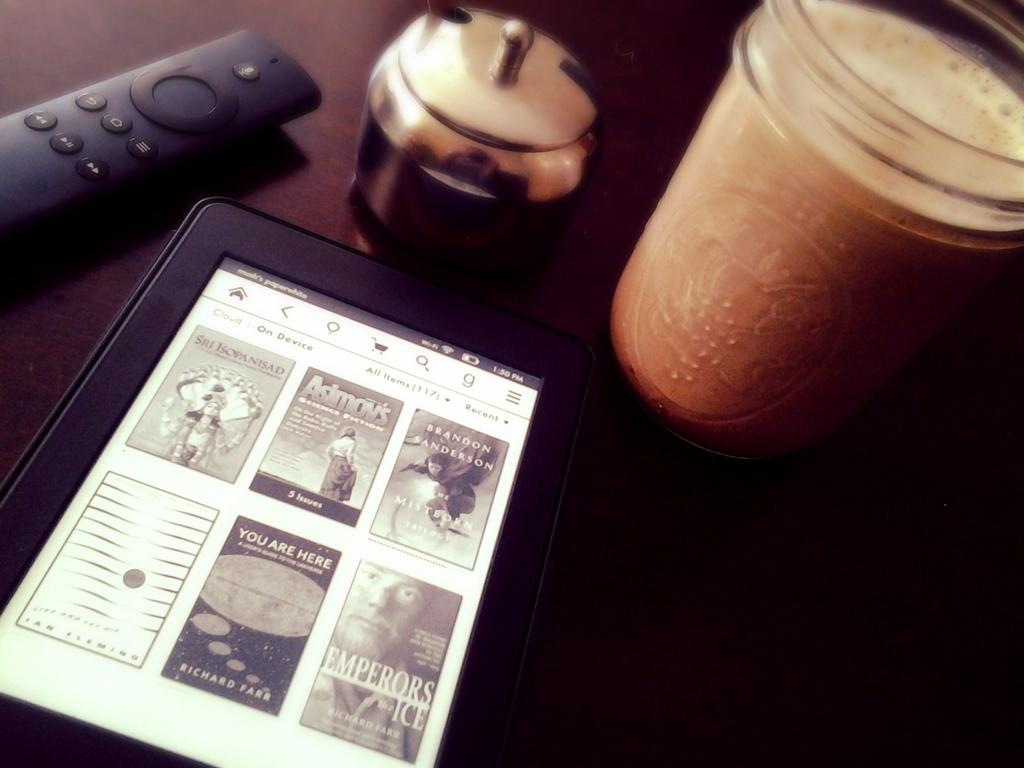<image>
Write a terse but informative summary of the picture. A Kindle is open and has a number of books displayed including one titled Emperors Ice. 